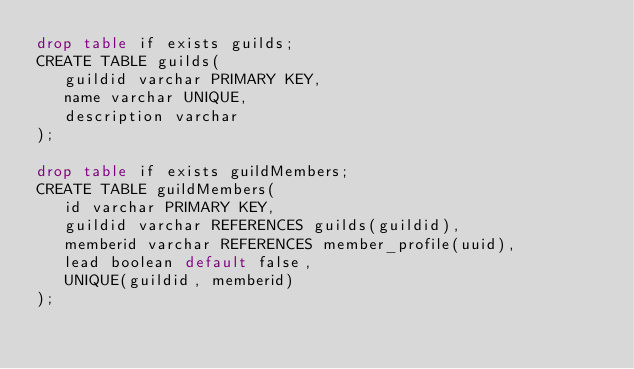<code> <loc_0><loc_0><loc_500><loc_500><_SQL_>drop table if exists guilds;
CREATE TABLE guilds(
   guildid varchar PRIMARY KEY,
   name varchar UNIQUE,
   description varchar
);

drop table if exists guildMembers;
CREATE TABLE guildMembers(
   id varchar PRIMARY KEY,
   guildid varchar REFERENCES guilds(guildid),
   memberid varchar REFERENCES member_profile(uuid),
   lead boolean default false,
   UNIQUE(guildid, memberid)
);
</code> 